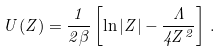<formula> <loc_0><loc_0><loc_500><loc_500>U ( Z ) = \frac { 1 } { 2 \beta } \left [ \ln | Z | - \frac { \Lambda } { 4 Z ^ { 2 } } \right ] \, .</formula> 